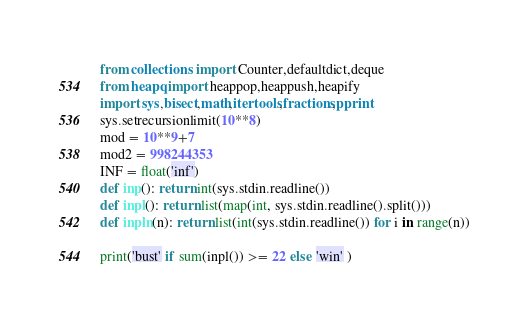<code> <loc_0><loc_0><loc_500><loc_500><_Python_>from collections import Counter,defaultdict,deque
from heapq import heappop,heappush,heapify
import sys,bisect,math,itertools,fractions,pprint
sys.setrecursionlimit(10**8)
mod = 10**9+7
mod2 = 998244353
INF = float('inf')
def inp(): return int(sys.stdin.readline())
def inpl(): return list(map(int, sys.stdin.readline().split()))
def inpln(n): return list(int(sys.stdin.readline()) for i in range(n))

print('bust' if sum(inpl()) >= 22 else 'win' )</code> 